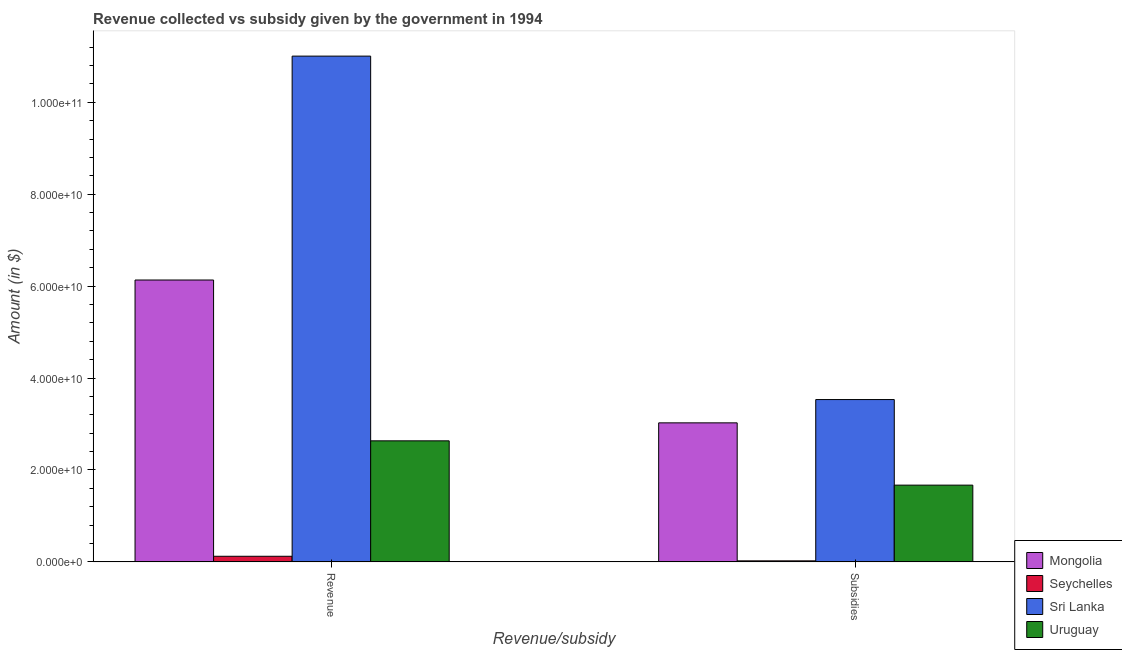How many different coloured bars are there?
Offer a terse response. 4. Are the number of bars on each tick of the X-axis equal?
Make the answer very short. Yes. How many bars are there on the 1st tick from the right?
Keep it short and to the point. 4. What is the label of the 1st group of bars from the left?
Give a very brief answer. Revenue. What is the amount of revenue collected in Mongolia?
Give a very brief answer. 6.13e+1. Across all countries, what is the maximum amount of revenue collected?
Offer a terse response. 1.10e+11. Across all countries, what is the minimum amount of subsidies given?
Offer a very short reply. 2.28e+08. In which country was the amount of revenue collected maximum?
Ensure brevity in your answer.  Sri Lanka. In which country was the amount of revenue collected minimum?
Your answer should be compact. Seychelles. What is the total amount of subsidies given in the graph?
Make the answer very short. 8.25e+1. What is the difference between the amount of revenue collected in Mongolia and that in Seychelles?
Your answer should be compact. 6.01e+1. What is the difference between the amount of subsidies given in Seychelles and the amount of revenue collected in Uruguay?
Ensure brevity in your answer.  -2.61e+1. What is the average amount of revenue collected per country?
Give a very brief answer. 4.97e+1. What is the difference between the amount of subsidies given and amount of revenue collected in Uruguay?
Offer a terse response. -9.64e+09. In how many countries, is the amount of revenue collected greater than 8000000000 $?
Your answer should be compact. 3. What is the ratio of the amount of revenue collected in Mongolia to that in Uruguay?
Provide a succinct answer. 2.33. What does the 3rd bar from the left in Subsidies represents?
Your answer should be very brief. Sri Lanka. What does the 4th bar from the right in Revenue represents?
Your response must be concise. Mongolia. How many bars are there?
Your response must be concise. 8. How many countries are there in the graph?
Your response must be concise. 4. Are the values on the major ticks of Y-axis written in scientific E-notation?
Ensure brevity in your answer.  Yes. Where does the legend appear in the graph?
Offer a terse response. Bottom right. How many legend labels are there?
Provide a succinct answer. 4. What is the title of the graph?
Your response must be concise. Revenue collected vs subsidy given by the government in 1994. Does "Macedonia" appear as one of the legend labels in the graph?
Provide a succinct answer. No. What is the label or title of the X-axis?
Make the answer very short. Revenue/subsidy. What is the label or title of the Y-axis?
Ensure brevity in your answer.  Amount (in $). What is the Amount (in $) of Mongolia in Revenue?
Make the answer very short. 6.13e+1. What is the Amount (in $) in Seychelles in Revenue?
Keep it short and to the point. 1.23e+09. What is the Amount (in $) in Sri Lanka in Revenue?
Your response must be concise. 1.10e+11. What is the Amount (in $) in Uruguay in Revenue?
Make the answer very short. 2.63e+1. What is the Amount (in $) of Mongolia in Subsidies?
Ensure brevity in your answer.  3.03e+1. What is the Amount (in $) of Seychelles in Subsidies?
Make the answer very short. 2.28e+08. What is the Amount (in $) of Sri Lanka in Subsidies?
Your answer should be compact. 3.53e+1. What is the Amount (in $) in Uruguay in Subsidies?
Make the answer very short. 1.67e+1. Across all Revenue/subsidy, what is the maximum Amount (in $) of Mongolia?
Make the answer very short. 6.13e+1. Across all Revenue/subsidy, what is the maximum Amount (in $) in Seychelles?
Your answer should be compact. 1.23e+09. Across all Revenue/subsidy, what is the maximum Amount (in $) in Sri Lanka?
Ensure brevity in your answer.  1.10e+11. Across all Revenue/subsidy, what is the maximum Amount (in $) in Uruguay?
Your answer should be compact. 2.63e+1. Across all Revenue/subsidy, what is the minimum Amount (in $) in Mongolia?
Offer a very short reply. 3.03e+1. Across all Revenue/subsidy, what is the minimum Amount (in $) in Seychelles?
Provide a short and direct response. 2.28e+08. Across all Revenue/subsidy, what is the minimum Amount (in $) of Sri Lanka?
Provide a short and direct response. 3.53e+1. Across all Revenue/subsidy, what is the minimum Amount (in $) in Uruguay?
Offer a terse response. 1.67e+1. What is the total Amount (in $) of Mongolia in the graph?
Provide a succinct answer. 9.16e+1. What is the total Amount (in $) of Seychelles in the graph?
Your response must be concise. 1.45e+09. What is the total Amount (in $) of Sri Lanka in the graph?
Ensure brevity in your answer.  1.45e+11. What is the total Amount (in $) of Uruguay in the graph?
Your answer should be compact. 4.30e+1. What is the difference between the Amount (in $) of Mongolia in Revenue and that in Subsidies?
Give a very brief answer. 3.11e+1. What is the difference between the Amount (in $) of Seychelles in Revenue and that in Subsidies?
Your answer should be very brief. 9.98e+08. What is the difference between the Amount (in $) in Sri Lanka in Revenue and that in Subsidies?
Offer a very short reply. 7.47e+1. What is the difference between the Amount (in $) of Uruguay in Revenue and that in Subsidies?
Your answer should be compact. 9.64e+09. What is the difference between the Amount (in $) of Mongolia in Revenue and the Amount (in $) of Seychelles in Subsidies?
Your answer should be very brief. 6.11e+1. What is the difference between the Amount (in $) of Mongolia in Revenue and the Amount (in $) of Sri Lanka in Subsidies?
Offer a very short reply. 2.60e+1. What is the difference between the Amount (in $) in Mongolia in Revenue and the Amount (in $) in Uruguay in Subsidies?
Your response must be concise. 4.46e+1. What is the difference between the Amount (in $) of Seychelles in Revenue and the Amount (in $) of Sri Lanka in Subsidies?
Offer a terse response. -3.41e+1. What is the difference between the Amount (in $) of Seychelles in Revenue and the Amount (in $) of Uruguay in Subsidies?
Make the answer very short. -1.55e+1. What is the difference between the Amount (in $) of Sri Lanka in Revenue and the Amount (in $) of Uruguay in Subsidies?
Your response must be concise. 9.33e+1. What is the average Amount (in $) of Mongolia per Revenue/subsidy?
Make the answer very short. 4.58e+1. What is the average Amount (in $) of Seychelles per Revenue/subsidy?
Offer a very short reply. 7.27e+08. What is the average Amount (in $) of Sri Lanka per Revenue/subsidy?
Make the answer very short. 7.27e+1. What is the average Amount (in $) of Uruguay per Revenue/subsidy?
Keep it short and to the point. 2.15e+1. What is the difference between the Amount (in $) of Mongolia and Amount (in $) of Seychelles in Revenue?
Provide a short and direct response. 6.01e+1. What is the difference between the Amount (in $) in Mongolia and Amount (in $) in Sri Lanka in Revenue?
Offer a very short reply. -4.87e+1. What is the difference between the Amount (in $) of Mongolia and Amount (in $) of Uruguay in Revenue?
Your answer should be compact. 3.50e+1. What is the difference between the Amount (in $) in Seychelles and Amount (in $) in Sri Lanka in Revenue?
Offer a terse response. -1.09e+11. What is the difference between the Amount (in $) in Seychelles and Amount (in $) in Uruguay in Revenue?
Make the answer very short. -2.51e+1. What is the difference between the Amount (in $) in Sri Lanka and Amount (in $) in Uruguay in Revenue?
Make the answer very short. 8.37e+1. What is the difference between the Amount (in $) in Mongolia and Amount (in $) in Seychelles in Subsidies?
Provide a succinct answer. 3.00e+1. What is the difference between the Amount (in $) in Mongolia and Amount (in $) in Sri Lanka in Subsidies?
Ensure brevity in your answer.  -5.07e+09. What is the difference between the Amount (in $) of Mongolia and Amount (in $) of Uruguay in Subsidies?
Offer a terse response. 1.36e+1. What is the difference between the Amount (in $) in Seychelles and Amount (in $) in Sri Lanka in Subsidies?
Ensure brevity in your answer.  -3.51e+1. What is the difference between the Amount (in $) of Seychelles and Amount (in $) of Uruguay in Subsidies?
Provide a short and direct response. -1.65e+1. What is the difference between the Amount (in $) of Sri Lanka and Amount (in $) of Uruguay in Subsidies?
Your answer should be very brief. 1.86e+1. What is the ratio of the Amount (in $) in Mongolia in Revenue to that in Subsidies?
Your answer should be very brief. 2.03. What is the ratio of the Amount (in $) of Seychelles in Revenue to that in Subsidies?
Provide a succinct answer. 5.39. What is the ratio of the Amount (in $) in Sri Lanka in Revenue to that in Subsidies?
Provide a succinct answer. 3.12. What is the ratio of the Amount (in $) in Uruguay in Revenue to that in Subsidies?
Keep it short and to the point. 1.58. What is the difference between the highest and the second highest Amount (in $) in Mongolia?
Your answer should be compact. 3.11e+1. What is the difference between the highest and the second highest Amount (in $) in Seychelles?
Your response must be concise. 9.98e+08. What is the difference between the highest and the second highest Amount (in $) in Sri Lanka?
Your answer should be compact. 7.47e+1. What is the difference between the highest and the second highest Amount (in $) in Uruguay?
Provide a succinct answer. 9.64e+09. What is the difference between the highest and the lowest Amount (in $) of Mongolia?
Your response must be concise. 3.11e+1. What is the difference between the highest and the lowest Amount (in $) in Seychelles?
Your answer should be compact. 9.98e+08. What is the difference between the highest and the lowest Amount (in $) of Sri Lanka?
Your answer should be very brief. 7.47e+1. What is the difference between the highest and the lowest Amount (in $) of Uruguay?
Keep it short and to the point. 9.64e+09. 